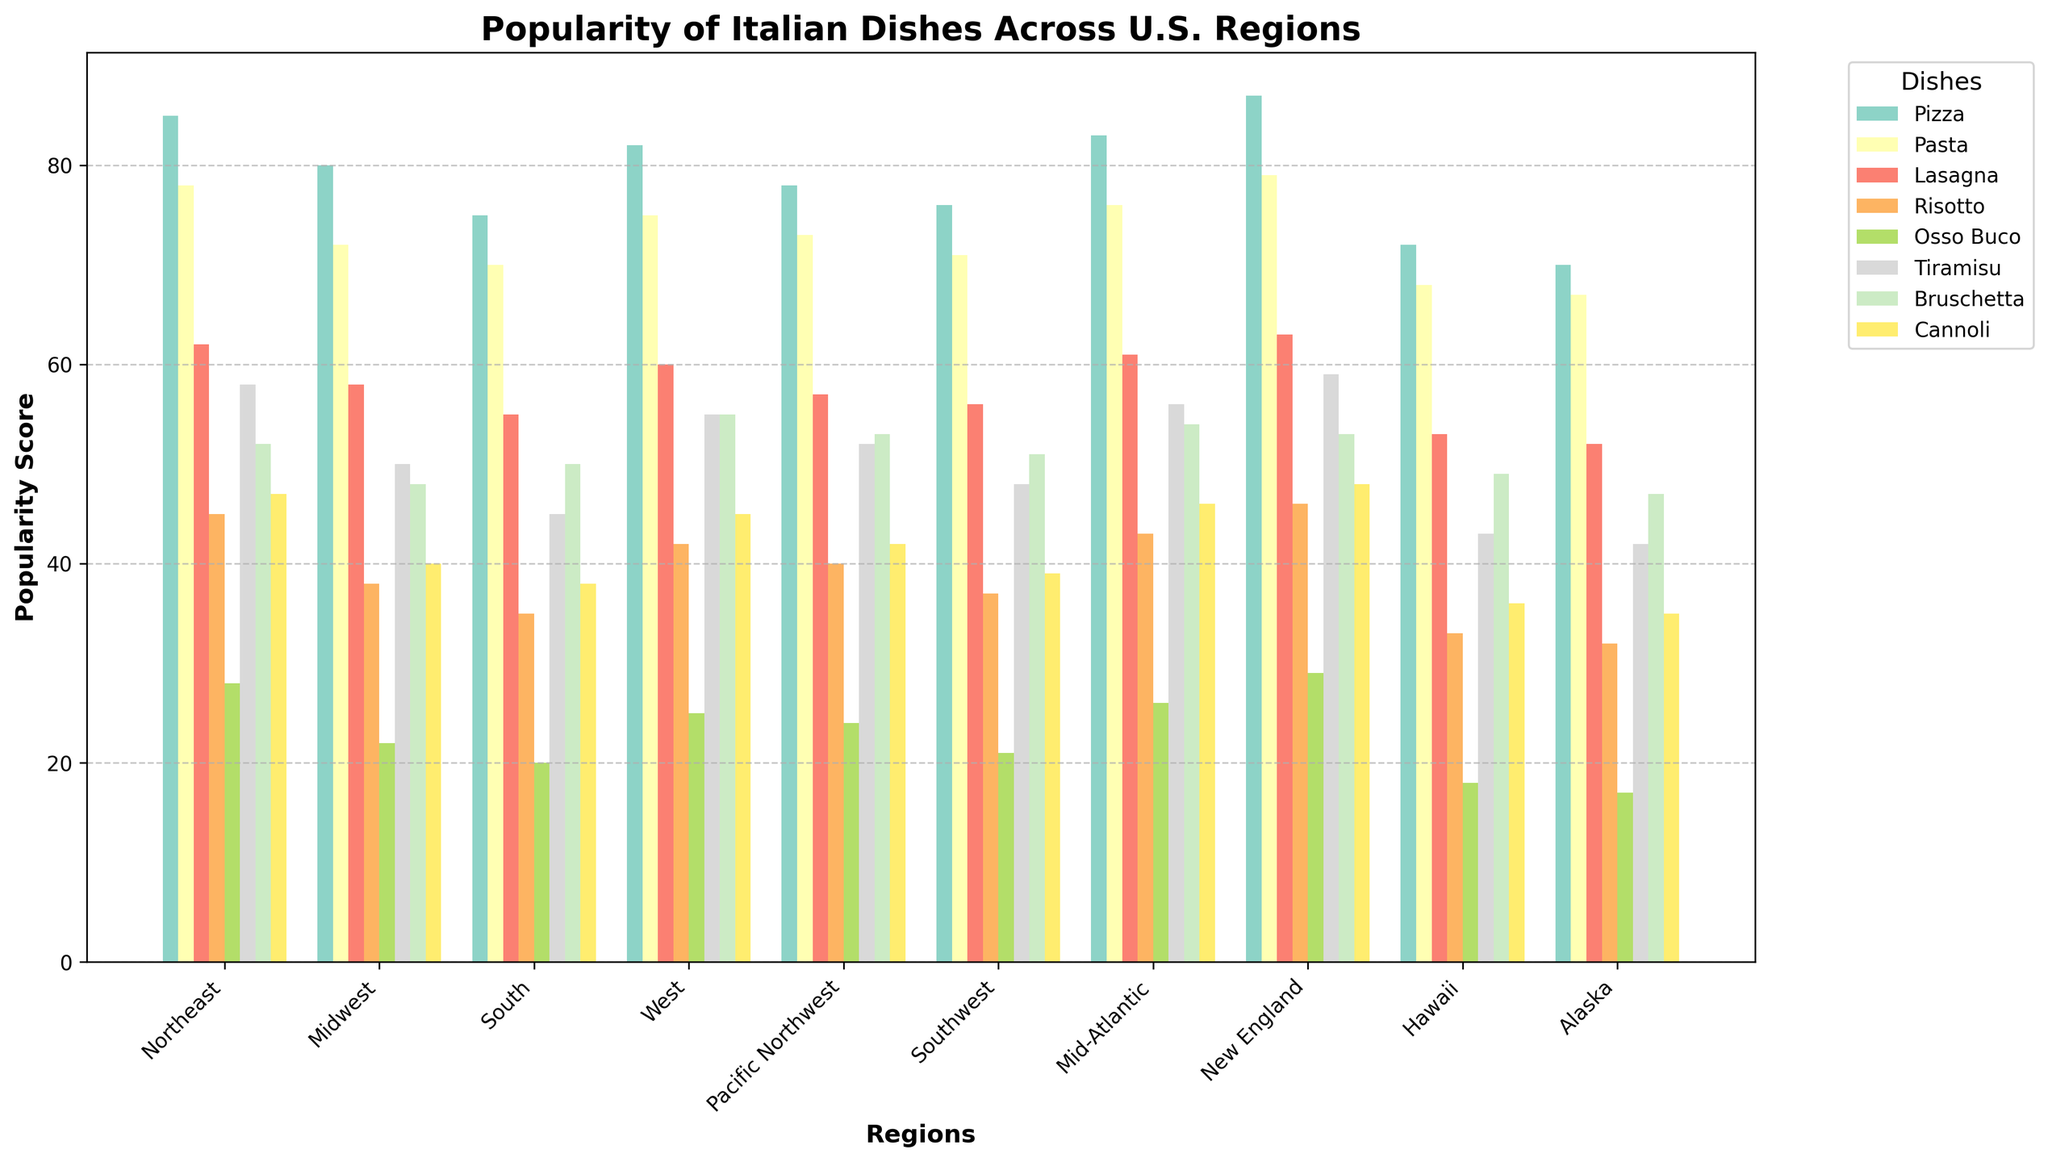What is the most popular Italian dish in the Northeast region? The heights of the bars in the figure represent the popularity scores of each dish. The highest bar in the Northeast region corresponds to Pizza.
Answer: Pizza Which region has the highest popularity score for Tiramisu? By comparing the heights of the bars for Tiramisu (usually a brown bar) across all regions, we can see that New England has the tallest Tiramisu bar.
Answer: New England Between the Pacific Northwest and the South regions, which one has a higher average popularity score across all dishes? Sum the scores for each dish in the Pacific Northwest (78+73+57+40+24+52+53+42) and the South (75+70+55+35+20+45+50+38). Then, divide each sum by the number of dishes (8). Pacific Northwest: (78+73+57+40+24+52+53+42)/8 = 52.75, South: (75+70+55+35+20+45+50+38)/8 = 48.5. The Pacific Northwest has a higher average.
Answer: Pacific Northwest What is the least popular Italian dish across all regions? Identify the dish with the lowest popularity scores consistently across all regions by comparing the heights of the bars. Osso Buco usually has the shortest bars in each region.
Answer: Osso Buco Which region has the highest overall sum of popularity scores for all dishes? Calculate the total popularity score for all dishes in each region and compare. E.g., Northeast: 85+78+62+45+28+58+52+47=455, etc. New England has the highest total sum (87+79+63+46+29+59+53+48 = 464).
Answer: New England In which region is Cannoli more popular than Risotto by the largest margin? Subtract the popularity score of Risotto from Cannoli in each region and identify the largest positive difference. E.g., Northeast: 47-45=2, Midwest: 40-38=2, etc. The largest difference is in Alaska (35-32=3).
Answer: Alaska Which dish shows the least variation in popularity score across the regions? Determine the range (max-min) for each dish's popularity scores across regions and identify the smallest range. E.g., Tiramisu: max=59, min=42, range=17. Bruschetta has the least variation with max=55, min=47, range=8.
Answer: Bruschetta Is Lasagna more popular in the Northeast or the West? Compare the heights of the bars for Lasagna in the Northeast and the West. Lasagna has a score of 62 in the Northeast and 60 in the West.
Answer: Northeast Which region has a higher popularity score for Pasta, Alaska or Hawaii? Compare the heights of the bars for Pasta in Alaska and Hawaii. Alaska has a score of 67 for Pasta, and Hawaii has a score of 68.
Answer: Hawaii 